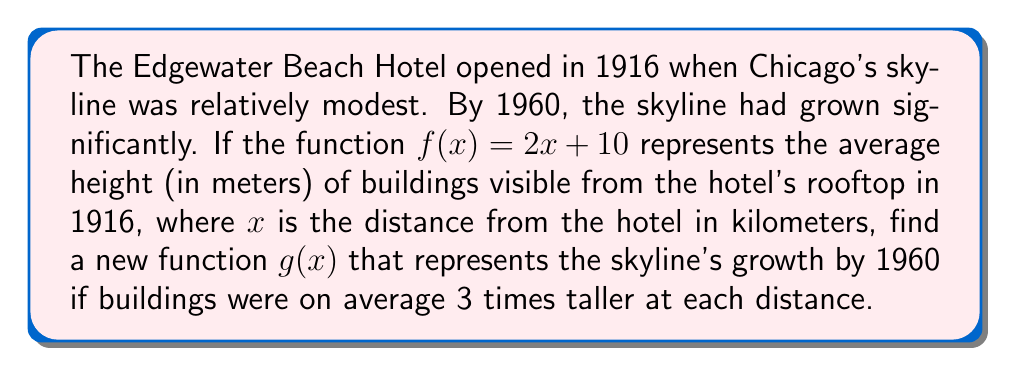Could you help me with this problem? To solve this problem, we need to scale the original function $f(x)$ to represent the growth of Chicago's skyline. Here's how we can approach it step-by-step:

1) The original function is $f(x) = 2x + 10$, where:
   - $x$ represents the distance from the hotel in kilometers
   - $f(x)$ represents the average height of buildings in meters

2) We're told that by 1960, buildings were on average 3 times taller at each distance.

3) To represent this growth, we need to multiply the entire function by 3:

   $g(x) = 3 \cdot f(x)$

4) Let's expand this:
   $g(x) = 3 \cdot (2x + 10)$

5) Distribute the 3:
   $g(x) = 6x + 30$

Therefore, the new function $g(x) = 6x + 30$ represents the skyline's growth by 1960.
Answer: $g(x) = 6x + 30$ 